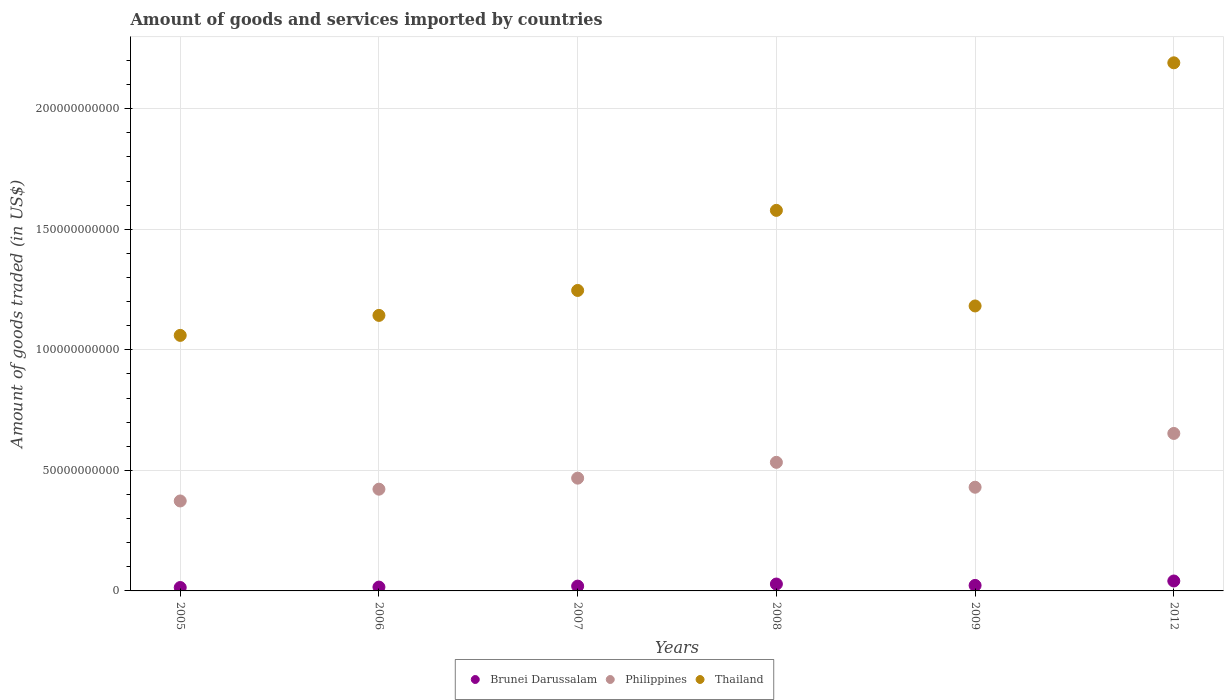Is the number of dotlines equal to the number of legend labels?
Provide a short and direct response. Yes. What is the total amount of goods and services imported in Philippines in 2009?
Your answer should be compact. 4.30e+1. Across all years, what is the maximum total amount of goods and services imported in Brunei Darussalam?
Provide a short and direct response. 4.12e+09. Across all years, what is the minimum total amount of goods and services imported in Brunei Darussalam?
Offer a terse response. 1.41e+09. What is the total total amount of goods and services imported in Brunei Darussalam in the graph?
Your response must be concise. 1.42e+1. What is the difference between the total amount of goods and services imported in Philippines in 2008 and that in 2012?
Provide a short and direct response. -1.20e+1. What is the difference between the total amount of goods and services imported in Philippines in 2006 and the total amount of goods and services imported in Brunei Darussalam in 2005?
Provide a succinct answer. 4.08e+1. What is the average total amount of goods and services imported in Thailand per year?
Your answer should be very brief. 1.40e+11. In the year 2007, what is the difference between the total amount of goods and services imported in Brunei Darussalam and total amount of goods and services imported in Philippines?
Offer a terse response. -4.48e+1. What is the ratio of the total amount of goods and services imported in Brunei Darussalam in 2006 to that in 2008?
Your answer should be compact. 0.56. Is the total amount of goods and services imported in Philippines in 2005 less than that in 2008?
Offer a terse response. Yes. What is the difference between the highest and the second highest total amount of goods and services imported in Philippines?
Your answer should be very brief. 1.20e+1. What is the difference between the highest and the lowest total amount of goods and services imported in Philippines?
Your answer should be very brief. 2.80e+1. Is the sum of the total amount of goods and services imported in Thailand in 2006 and 2012 greater than the maximum total amount of goods and services imported in Brunei Darussalam across all years?
Your response must be concise. Yes. Does the total amount of goods and services imported in Thailand monotonically increase over the years?
Your answer should be compact. No. Is the total amount of goods and services imported in Brunei Darussalam strictly greater than the total amount of goods and services imported in Philippines over the years?
Your answer should be compact. No. Is the total amount of goods and services imported in Thailand strictly less than the total amount of goods and services imported in Brunei Darussalam over the years?
Your answer should be very brief. No. What is the difference between two consecutive major ticks on the Y-axis?
Keep it short and to the point. 5.00e+1. Are the values on the major ticks of Y-axis written in scientific E-notation?
Provide a succinct answer. No. Does the graph contain any zero values?
Your answer should be compact. No. How are the legend labels stacked?
Ensure brevity in your answer.  Horizontal. What is the title of the graph?
Offer a very short reply. Amount of goods and services imported by countries. What is the label or title of the X-axis?
Provide a succinct answer. Years. What is the label or title of the Y-axis?
Your response must be concise. Amount of goods traded (in US$). What is the Amount of goods traded (in US$) in Brunei Darussalam in 2005?
Your response must be concise. 1.41e+09. What is the Amount of goods traded (in US$) in Philippines in 2005?
Give a very brief answer. 3.73e+1. What is the Amount of goods traded (in US$) in Thailand in 2005?
Your response must be concise. 1.06e+11. What is the Amount of goods traded (in US$) of Brunei Darussalam in 2006?
Ensure brevity in your answer.  1.59e+09. What is the Amount of goods traded (in US$) in Philippines in 2006?
Make the answer very short. 4.22e+1. What is the Amount of goods traded (in US$) in Thailand in 2006?
Your answer should be compact. 1.14e+11. What is the Amount of goods traded (in US$) of Brunei Darussalam in 2007?
Your answer should be compact. 1.99e+09. What is the Amount of goods traded (in US$) of Philippines in 2007?
Your answer should be compact. 4.68e+1. What is the Amount of goods traded (in US$) of Thailand in 2007?
Your answer should be compact. 1.25e+11. What is the Amount of goods traded (in US$) in Brunei Darussalam in 2008?
Offer a terse response. 2.86e+09. What is the Amount of goods traded (in US$) of Philippines in 2008?
Make the answer very short. 5.33e+1. What is the Amount of goods traded (in US$) of Thailand in 2008?
Give a very brief answer. 1.58e+11. What is the Amount of goods traded (in US$) of Brunei Darussalam in 2009?
Offer a very short reply. 2.28e+09. What is the Amount of goods traded (in US$) in Philippines in 2009?
Your response must be concise. 4.30e+1. What is the Amount of goods traded (in US$) of Thailand in 2009?
Provide a short and direct response. 1.18e+11. What is the Amount of goods traded (in US$) of Brunei Darussalam in 2012?
Provide a short and direct response. 4.12e+09. What is the Amount of goods traded (in US$) of Philippines in 2012?
Provide a short and direct response. 6.53e+1. What is the Amount of goods traded (in US$) of Thailand in 2012?
Offer a very short reply. 2.19e+11. Across all years, what is the maximum Amount of goods traded (in US$) of Brunei Darussalam?
Offer a very short reply. 4.12e+09. Across all years, what is the maximum Amount of goods traded (in US$) in Philippines?
Provide a short and direct response. 6.53e+1. Across all years, what is the maximum Amount of goods traded (in US$) of Thailand?
Provide a short and direct response. 2.19e+11. Across all years, what is the minimum Amount of goods traded (in US$) in Brunei Darussalam?
Provide a short and direct response. 1.41e+09. Across all years, what is the minimum Amount of goods traded (in US$) of Philippines?
Keep it short and to the point. 3.73e+1. Across all years, what is the minimum Amount of goods traded (in US$) of Thailand?
Make the answer very short. 1.06e+11. What is the total Amount of goods traded (in US$) of Brunei Darussalam in the graph?
Offer a very short reply. 1.42e+1. What is the total Amount of goods traded (in US$) of Philippines in the graph?
Make the answer very short. 2.88e+11. What is the total Amount of goods traded (in US$) of Thailand in the graph?
Provide a succinct answer. 8.40e+11. What is the difference between the Amount of goods traded (in US$) of Brunei Darussalam in 2005 and that in 2006?
Your answer should be very brief. -1.77e+08. What is the difference between the Amount of goods traded (in US$) in Philippines in 2005 and that in 2006?
Keep it short and to the point. -4.89e+09. What is the difference between the Amount of goods traded (in US$) in Thailand in 2005 and that in 2006?
Give a very brief answer. -8.29e+09. What is the difference between the Amount of goods traded (in US$) of Brunei Darussalam in 2005 and that in 2007?
Your response must be concise. -5.80e+08. What is the difference between the Amount of goods traded (in US$) of Philippines in 2005 and that in 2007?
Your response must be concise. -9.46e+09. What is the difference between the Amount of goods traded (in US$) in Thailand in 2005 and that in 2007?
Your response must be concise. -1.86e+1. What is the difference between the Amount of goods traded (in US$) of Brunei Darussalam in 2005 and that in 2008?
Ensure brevity in your answer.  -1.45e+09. What is the difference between the Amount of goods traded (in US$) of Philippines in 2005 and that in 2008?
Offer a terse response. -1.60e+1. What is the difference between the Amount of goods traded (in US$) in Thailand in 2005 and that in 2008?
Offer a terse response. -5.18e+1. What is the difference between the Amount of goods traded (in US$) in Brunei Darussalam in 2005 and that in 2009?
Give a very brief answer. -8.71e+08. What is the difference between the Amount of goods traded (in US$) of Philippines in 2005 and that in 2009?
Your answer should be very brief. -5.70e+09. What is the difference between the Amount of goods traded (in US$) of Thailand in 2005 and that in 2009?
Provide a short and direct response. -1.22e+1. What is the difference between the Amount of goods traded (in US$) in Brunei Darussalam in 2005 and that in 2012?
Offer a terse response. -2.70e+09. What is the difference between the Amount of goods traded (in US$) in Philippines in 2005 and that in 2012?
Provide a short and direct response. -2.80e+1. What is the difference between the Amount of goods traded (in US$) of Thailand in 2005 and that in 2012?
Provide a short and direct response. -1.13e+11. What is the difference between the Amount of goods traded (in US$) in Brunei Darussalam in 2006 and that in 2007?
Ensure brevity in your answer.  -4.03e+08. What is the difference between the Amount of goods traded (in US$) in Philippines in 2006 and that in 2007?
Provide a succinct answer. -4.58e+09. What is the difference between the Amount of goods traded (in US$) in Thailand in 2006 and that in 2007?
Ensure brevity in your answer.  -1.03e+1. What is the difference between the Amount of goods traded (in US$) in Brunei Darussalam in 2006 and that in 2008?
Provide a succinct answer. -1.27e+09. What is the difference between the Amount of goods traded (in US$) in Philippines in 2006 and that in 2008?
Your answer should be compact. -1.11e+1. What is the difference between the Amount of goods traded (in US$) of Thailand in 2006 and that in 2008?
Your answer should be very brief. -4.36e+1. What is the difference between the Amount of goods traded (in US$) of Brunei Darussalam in 2006 and that in 2009?
Ensure brevity in your answer.  -6.94e+08. What is the difference between the Amount of goods traded (in US$) in Philippines in 2006 and that in 2009?
Ensure brevity in your answer.  -8.09e+08. What is the difference between the Amount of goods traded (in US$) in Thailand in 2006 and that in 2009?
Your answer should be very brief. -3.92e+09. What is the difference between the Amount of goods traded (in US$) of Brunei Darussalam in 2006 and that in 2012?
Your answer should be compact. -2.53e+09. What is the difference between the Amount of goods traded (in US$) of Philippines in 2006 and that in 2012?
Your answer should be compact. -2.31e+1. What is the difference between the Amount of goods traded (in US$) in Thailand in 2006 and that in 2012?
Your answer should be compact. -1.05e+11. What is the difference between the Amount of goods traded (in US$) in Brunei Darussalam in 2007 and that in 2008?
Your answer should be compact. -8.66e+08. What is the difference between the Amount of goods traded (in US$) of Philippines in 2007 and that in 2008?
Offer a very short reply. -6.56e+09. What is the difference between the Amount of goods traded (in US$) of Thailand in 2007 and that in 2008?
Offer a very short reply. -3.32e+1. What is the difference between the Amount of goods traded (in US$) of Brunei Darussalam in 2007 and that in 2009?
Provide a succinct answer. -2.91e+08. What is the difference between the Amount of goods traded (in US$) of Philippines in 2007 and that in 2009?
Give a very brief answer. 3.77e+09. What is the difference between the Amount of goods traded (in US$) of Thailand in 2007 and that in 2009?
Offer a terse response. 6.43e+09. What is the difference between the Amount of goods traded (in US$) of Brunei Darussalam in 2007 and that in 2012?
Keep it short and to the point. -2.12e+09. What is the difference between the Amount of goods traded (in US$) in Philippines in 2007 and that in 2012?
Your answer should be very brief. -1.85e+1. What is the difference between the Amount of goods traded (in US$) in Thailand in 2007 and that in 2012?
Give a very brief answer. -9.44e+1. What is the difference between the Amount of goods traded (in US$) of Brunei Darussalam in 2008 and that in 2009?
Offer a very short reply. 5.75e+08. What is the difference between the Amount of goods traded (in US$) of Philippines in 2008 and that in 2009?
Give a very brief answer. 1.03e+1. What is the difference between the Amount of goods traded (in US$) of Thailand in 2008 and that in 2009?
Your response must be concise. 3.96e+1. What is the difference between the Amount of goods traded (in US$) in Brunei Darussalam in 2008 and that in 2012?
Offer a very short reply. -1.26e+09. What is the difference between the Amount of goods traded (in US$) in Philippines in 2008 and that in 2012?
Provide a succinct answer. -1.20e+1. What is the difference between the Amount of goods traded (in US$) of Thailand in 2008 and that in 2012?
Your answer should be compact. -6.12e+1. What is the difference between the Amount of goods traded (in US$) of Brunei Darussalam in 2009 and that in 2012?
Provide a short and direct response. -1.83e+09. What is the difference between the Amount of goods traded (in US$) in Philippines in 2009 and that in 2012?
Give a very brief answer. -2.23e+1. What is the difference between the Amount of goods traded (in US$) in Thailand in 2009 and that in 2012?
Your answer should be very brief. -1.01e+11. What is the difference between the Amount of goods traded (in US$) in Brunei Darussalam in 2005 and the Amount of goods traded (in US$) in Philippines in 2006?
Make the answer very short. -4.08e+1. What is the difference between the Amount of goods traded (in US$) in Brunei Darussalam in 2005 and the Amount of goods traded (in US$) in Thailand in 2006?
Make the answer very short. -1.13e+11. What is the difference between the Amount of goods traded (in US$) of Philippines in 2005 and the Amount of goods traded (in US$) of Thailand in 2006?
Give a very brief answer. -7.70e+1. What is the difference between the Amount of goods traded (in US$) of Brunei Darussalam in 2005 and the Amount of goods traded (in US$) of Philippines in 2007?
Make the answer very short. -4.54e+1. What is the difference between the Amount of goods traded (in US$) of Brunei Darussalam in 2005 and the Amount of goods traded (in US$) of Thailand in 2007?
Provide a succinct answer. -1.23e+11. What is the difference between the Amount of goods traded (in US$) in Philippines in 2005 and the Amount of goods traded (in US$) in Thailand in 2007?
Offer a terse response. -8.73e+1. What is the difference between the Amount of goods traded (in US$) of Brunei Darussalam in 2005 and the Amount of goods traded (in US$) of Philippines in 2008?
Your answer should be very brief. -5.19e+1. What is the difference between the Amount of goods traded (in US$) of Brunei Darussalam in 2005 and the Amount of goods traded (in US$) of Thailand in 2008?
Your answer should be very brief. -1.56e+11. What is the difference between the Amount of goods traded (in US$) in Philippines in 2005 and the Amount of goods traded (in US$) in Thailand in 2008?
Your answer should be very brief. -1.21e+11. What is the difference between the Amount of goods traded (in US$) of Brunei Darussalam in 2005 and the Amount of goods traded (in US$) of Philippines in 2009?
Keep it short and to the point. -4.16e+1. What is the difference between the Amount of goods traded (in US$) in Brunei Darussalam in 2005 and the Amount of goods traded (in US$) in Thailand in 2009?
Your answer should be very brief. -1.17e+11. What is the difference between the Amount of goods traded (in US$) in Philippines in 2005 and the Amount of goods traded (in US$) in Thailand in 2009?
Provide a succinct answer. -8.09e+1. What is the difference between the Amount of goods traded (in US$) of Brunei Darussalam in 2005 and the Amount of goods traded (in US$) of Philippines in 2012?
Your response must be concise. -6.39e+1. What is the difference between the Amount of goods traded (in US$) of Brunei Darussalam in 2005 and the Amount of goods traded (in US$) of Thailand in 2012?
Your answer should be compact. -2.18e+11. What is the difference between the Amount of goods traded (in US$) in Philippines in 2005 and the Amount of goods traded (in US$) in Thailand in 2012?
Provide a short and direct response. -1.82e+11. What is the difference between the Amount of goods traded (in US$) in Brunei Darussalam in 2006 and the Amount of goods traded (in US$) in Philippines in 2007?
Offer a terse response. -4.52e+1. What is the difference between the Amount of goods traded (in US$) in Brunei Darussalam in 2006 and the Amount of goods traded (in US$) in Thailand in 2007?
Provide a short and direct response. -1.23e+11. What is the difference between the Amount of goods traded (in US$) in Philippines in 2006 and the Amount of goods traded (in US$) in Thailand in 2007?
Provide a short and direct response. -8.24e+1. What is the difference between the Amount of goods traded (in US$) of Brunei Darussalam in 2006 and the Amount of goods traded (in US$) of Philippines in 2008?
Provide a short and direct response. -5.17e+1. What is the difference between the Amount of goods traded (in US$) in Brunei Darussalam in 2006 and the Amount of goods traded (in US$) in Thailand in 2008?
Make the answer very short. -1.56e+11. What is the difference between the Amount of goods traded (in US$) in Philippines in 2006 and the Amount of goods traded (in US$) in Thailand in 2008?
Make the answer very short. -1.16e+11. What is the difference between the Amount of goods traded (in US$) of Brunei Darussalam in 2006 and the Amount of goods traded (in US$) of Philippines in 2009?
Give a very brief answer. -4.14e+1. What is the difference between the Amount of goods traded (in US$) of Brunei Darussalam in 2006 and the Amount of goods traded (in US$) of Thailand in 2009?
Ensure brevity in your answer.  -1.17e+11. What is the difference between the Amount of goods traded (in US$) of Philippines in 2006 and the Amount of goods traded (in US$) of Thailand in 2009?
Provide a succinct answer. -7.60e+1. What is the difference between the Amount of goods traded (in US$) of Brunei Darussalam in 2006 and the Amount of goods traded (in US$) of Philippines in 2012?
Offer a terse response. -6.37e+1. What is the difference between the Amount of goods traded (in US$) of Brunei Darussalam in 2006 and the Amount of goods traded (in US$) of Thailand in 2012?
Provide a succinct answer. -2.17e+11. What is the difference between the Amount of goods traded (in US$) of Philippines in 2006 and the Amount of goods traded (in US$) of Thailand in 2012?
Give a very brief answer. -1.77e+11. What is the difference between the Amount of goods traded (in US$) in Brunei Darussalam in 2007 and the Amount of goods traded (in US$) in Philippines in 2008?
Make the answer very short. -5.13e+1. What is the difference between the Amount of goods traded (in US$) of Brunei Darussalam in 2007 and the Amount of goods traded (in US$) of Thailand in 2008?
Provide a succinct answer. -1.56e+11. What is the difference between the Amount of goods traded (in US$) of Philippines in 2007 and the Amount of goods traded (in US$) of Thailand in 2008?
Offer a very short reply. -1.11e+11. What is the difference between the Amount of goods traded (in US$) of Brunei Darussalam in 2007 and the Amount of goods traded (in US$) of Philippines in 2009?
Your response must be concise. -4.10e+1. What is the difference between the Amount of goods traded (in US$) in Brunei Darussalam in 2007 and the Amount of goods traded (in US$) in Thailand in 2009?
Give a very brief answer. -1.16e+11. What is the difference between the Amount of goods traded (in US$) in Philippines in 2007 and the Amount of goods traded (in US$) in Thailand in 2009?
Make the answer very short. -7.14e+1. What is the difference between the Amount of goods traded (in US$) of Brunei Darussalam in 2007 and the Amount of goods traded (in US$) of Philippines in 2012?
Your answer should be very brief. -6.33e+1. What is the difference between the Amount of goods traded (in US$) in Brunei Darussalam in 2007 and the Amount of goods traded (in US$) in Thailand in 2012?
Offer a very short reply. -2.17e+11. What is the difference between the Amount of goods traded (in US$) in Philippines in 2007 and the Amount of goods traded (in US$) in Thailand in 2012?
Ensure brevity in your answer.  -1.72e+11. What is the difference between the Amount of goods traded (in US$) of Brunei Darussalam in 2008 and the Amount of goods traded (in US$) of Philippines in 2009?
Your answer should be very brief. -4.01e+1. What is the difference between the Amount of goods traded (in US$) of Brunei Darussalam in 2008 and the Amount of goods traded (in US$) of Thailand in 2009?
Offer a terse response. -1.15e+11. What is the difference between the Amount of goods traded (in US$) of Philippines in 2008 and the Amount of goods traded (in US$) of Thailand in 2009?
Your answer should be very brief. -6.49e+1. What is the difference between the Amount of goods traded (in US$) in Brunei Darussalam in 2008 and the Amount of goods traded (in US$) in Philippines in 2012?
Your answer should be very brief. -6.25e+1. What is the difference between the Amount of goods traded (in US$) in Brunei Darussalam in 2008 and the Amount of goods traded (in US$) in Thailand in 2012?
Give a very brief answer. -2.16e+11. What is the difference between the Amount of goods traded (in US$) of Philippines in 2008 and the Amount of goods traded (in US$) of Thailand in 2012?
Ensure brevity in your answer.  -1.66e+11. What is the difference between the Amount of goods traded (in US$) of Brunei Darussalam in 2009 and the Amount of goods traded (in US$) of Philippines in 2012?
Ensure brevity in your answer.  -6.30e+1. What is the difference between the Amount of goods traded (in US$) of Brunei Darussalam in 2009 and the Amount of goods traded (in US$) of Thailand in 2012?
Offer a terse response. -2.17e+11. What is the difference between the Amount of goods traded (in US$) of Philippines in 2009 and the Amount of goods traded (in US$) of Thailand in 2012?
Ensure brevity in your answer.  -1.76e+11. What is the average Amount of goods traded (in US$) in Brunei Darussalam per year?
Your answer should be compact. 2.37e+09. What is the average Amount of goods traded (in US$) in Philippines per year?
Your response must be concise. 4.80e+1. What is the average Amount of goods traded (in US$) of Thailand per year?
Provide a short and direct response. 1.40e+11. In the year 2005, what is the difference between the Amount of goods traded (in US$) of Brunei Darussalam and Amount of goods traded (in US$) of Philippines?
Offer a very short reply. -3.59e+1. In the year 2005, what is the difference between the Amount of goods traded (in US$) in Brunei Darussalam and Amount of goods traded (in US$) in Thailand?
Give a very brief answer. -1.05e+11. In the year 2005, what is the difference between the Amount of goods traded (in US$) in Philippines and Amount of goods traded (in US$) in Thailand?
Your answer should be compact. -6.87e+1. In the year 2006, what is the difference between the Amount of goods traded (in US$) in Brunei Darussalam and Amount of goods traded (in US$) in Philippines?
Offer a terse response. -4.06e+1. In the year 2006, what is the difference between the Amount of goods traded (in US$) in Brunei Darussalam and Amount of goods traded (in US$) in Thailand?
Give a very brief answer. -1.13e+11. In the year 2006, what is the difference between the Amount of goods traded (in US$) in Philippines and Amount of goods traded (in US$) in Thailand?
Ensure brevity in your answer.  -7.21e+1. In the year 2007, what is the difference between the Amount of goods traded (in US$) of Brunei Darussalam and Amount of goods traded (in US$) of Philippines?
Give a very brief answer. -4.48e+1. In the year 2007, what is the difference between the Amount of goods traded (in US$) of Brunei Darussalam and Amount of goods traded (in US$) of Thailand?
Your response must be concise. -1.23e+11. In the year 2007, what is the difference between the Amount of goods traded (in US$) in Philippines and Amount of goods traded (in US$) in Thailand?
Make the answer very short. -7.78e+1. In the year 2008, what is the difference between the Amount of goods traded (in US$) in Brunei Darussalam and Amount of goods traded (in US$) in Philippines?
Offer a terse response. -5.05e+1. In the year 2008, what is the difference between the Amount of goods traded (in US$) of Brunei Darussalam and Amount of goods traded (in US$) of Thailand?
Offer a very short reply. -1.55e+11. In the year 2008, what is the difference between the Amount of goods traded (in US$) in Philippines and Amount of goods traded (in US$) in Thailand?
Offer a terse response. -1.04e+11. In the year 2009, what is the difference between the Amount of goods traded (in US$) of Brunei Darussalam and Amount of goods traded (in US$) of Philippines?
Your response must be concise. -4.07e+1. In the year 2009, what is the difference between the Amount of goods traded (in US$) in Brunei Darussalam and Amount of goods traded (in US$) in Thailand?
Your response must be concise. -1.16e+11. In the year 2009, what is the difference between the Amount of goods traded (in US$) in Philippines and Amount of goods traded (in US$) in Thailand?
Provide a succinct answer. -7.52e+1. In the year 2012, what is the difference between the Amount of goods traded (in US$) of Brunei Darussalam and Amount of goods traded (in US$) of Philippines?
Your answer should be very brief. -6.12e+1. In the year 2012, what is the difference between the Amount of goods traded (in US$) in Brunei Darussalam and Amount of goods traded (in US$) in Thailand?
Offer a terse response. -2.15e+11. In the year 2012, what is the difference between the Amount of goods traded (in US$) in Philippines and Amount of goods traded (in US$) in Thailand?
Your answer should be very brief. -1.54e+11. What is the ratio of the Amount of goods traded (in US$) of Brunei Darussalam in 2005 to that in 2006?
Make the answer very short. 0.89. What is the ratio of the Amount of goods traded (in US$) of Philippines in 2005 to that in 2006?
Make the answer very short. 0.88. What is the ratio of the Amount of goods traded (in US$) of Thailand in 2005 to that in 2006?
Your answer should be compact. 0.93. What is the ratio of the Amount of goods traded (in US$) of Brunei Darussalam in 2005 to that in 2007?
Ensure brevity in your answer.  0.71. What is the ratio of the Amount of goods traded (in US$) of Philippines in 2005 to that in 2007?
Ensure brevity in your answer.  0.8. What is the ratio of the Amount of goods traded (in US$) in Thailand in 2005 to that in 2007?
Your answer should be compact. 0.85. What is the ratio of the Amount of goods traded (in US$) of Brunei Darussalam in 2005 to that in 2008?
Offer a very short reply. 0.49. What is the ratio of the Amount of goods traded (in US$) of Philippines in 2005 to that in 2008?
Provide a short and direct response. 0.7. What is the ratio of the Amount of goods traded (in US$) of Thailand in 2005 to that in 2008?
Offer a terse response. 0.67. What is the ratio of the Amount of goods traded (in US$) of Brunei Darussalam in 2005 to that in 2009?
Offer a very short reply. 0.62. What is the ratio of the Amount of goods traded (in US$) in Philippines in 2005 to that in 2009?
Your answer should be compact. 0.87. What is the ratio of the Amount of goods traded (in US$) in Thailand in 2005 to that in 2009?
Your answer should be very brief. 0.9. What is the ratio of the Amount of goods traded (in US$) in Brunei Darussalam in 2005 to that in 2012?
Keep it short and to the point. 0.34. What is the ratio of the Amount of goods traded (in US$) of Philippines in 2005 to that in 2012?
Provide a short and direct response. 0.57. What is the ratio of the Amount of goods traded (in US$) of Thailand in 2005 to that in 2012?
Ensure brevity in your answer.  0.48. What is the ratio of the Amount of goods traded (in US$) in Brunei Darussalam in 2006 to that in 2007?
Ensure brevity in your answer.  0.8. What is the ratio of the Amount of goods traded (in US$) in Philippines in 2006 to that in 2007?
Give a very brief answer. 0.9. What is the ratio of the Amount of goods traded (in US$) of Thailand in 2006 to that in 2007?
Keep it short and to the point. 0.92. What is the ratio of the Amount of goods traded (in US$) in Brunei Darussalam in 2006 to that in 2008?
Provide a short and direct response. 0.56. What is the ratio of the Amount of goods traded (in US$) in Philippines in 2006 to that in 2008?
Provide a short and direct response. 0.79. What is the ratio of the Amount of goods traded (in US$) in Thailand in 2006 to that in 2008?
Ensure brevity in your answer.  0.72. What is the ratio of the Amount of goods traded (in US$) in Brunei Darussalam in 2006 to that in 2009?
Keep it short and to the point. 0.7. What is the ratio of the Amount of goods traded (in US$) of Philippines in 2006 to that in 2009?
Your answer should be compact. 0.98. What is the ratio of the Amount of goods traded (in US$) in Thailand in 2006 to that in 2009?
Make the answer very short. 0.97. What is the ratio of the Amount of goods traded (in US$) of Brunei Darussalam in 2006 to that in 2012?
Ensure brevity in your answer.  0.39. What is the ratio of the Amount of goods traded (in US$) in Philippines in 2006 to that in 2012?
Your answer should be compact. 0.65. What is the ratio of the Amount of goods traded (in US$) of Thailand in 2006 to that in 2012?
Provide a short and direct response. 0.52. What is the ratio of the Amount of goods traded (in US$) of Brunei Darussalam in 2007 to that in 2008?
Give a very brief answer. 0.7. What is the ratio of the Amount of goods traded (in US$) of Philippines in 2007 to that in 2008?
Make the answer very short. 0.88. What is the ratio of the Amount of goods traded (in US$) in Thailand in 2007 to that in 2008?
Your response must be concise. 0.79. What is the ratio of the Amount of goods traded (in US$) of Brunei Darussalam in 2007 to that in 2009?
Keep it short and to the point. 0.87. What is the ratio of the Amount of goods traded (in US$) in Philippines in 2007 to that in 2009?
Your answer should be very brief. 1.09. What is the ratio of the Amount of goods traded (in US$) of Thailand in 2007 to that in 2009?
Keep it short and to the point. 1.05. What is the ratio of the Amount of goods traded (in US$) in Brunei Darussalam in 2007 to that in 2012?
Offer a very short reply. 0.48. What is the ratio of the Amount of goods traded (in US$) of Philippines in 2007 to that in 2012?
Provide a succinct answer. 0.72. What is the ratio of the Amount of goods traded (in US$) of Thailand in 2007 to that in 2012?
Your answer should be very brief. 0.57. What is the ratio of the Amount of goods traded (in US$) in Brunei Darussalam in 2008 to that in 2009?
Your response must be concise. 1.25. What is the ratio of the Amount of goods traded (in US$) in Philippines in 2008 to that in 2009?
Offer a terse response. 1.24. What is the ratio of the Amount of goods traded (in US$) in Thailand in 2008 to that in 2009?
Make the answer very short. 1.34. What is the ratio of the Amount of goods traded (in US$) of Brunei Darussalam in 2008 to that in 2012?
Provide a succinct answer. 0.69. What is the ratio of the Amount of goods traded (in US$) of Philippines in 2008 to that in 2012?
Ensure brevity in your answer.  0.82. What is the ratio of the Amount of goods traded (in US$) in Thailand in 2008 to that in 2012?
Your answer should be very brief. 0.72. What is the ratio of the Amount of goods traded (in US$) in Brunei Darussalam in 2009 to that in 2012?
Your answer should be very brief. 0.55. What is the ratio of the Amount of goods traded (in US$) of Philippines in 2009 to that in 2012?
Provide a short and direct response. 0.66. What is the ratio of the Amount of goods traded (in US$) of Thailand in 2009 to that in 2012?
Provide a short and direct response. 0.54. What is the difference between the highest and the second highest Amount of goods traded (in US$) of Brunei Darussalam?
Your response must be concise. 1.26e+09. What is the difference between the highest and the second highest Amount of goods traded (in US$) of Philippines?
Your response must be concise. 1.20e+1. What is the difference between the highest and the second highest Amount of goods traded (in US$) of Thailand?
Your answer should be very brief. 6.12e+1. What is the difference between the highest and the lowest Amount of goods traded (in US$) of Brunei Darussalam?
Make the answer very short. 2.70e+09. What is the difference between the highest and the lowest Amount of goods traded (in US$) of Philippines?
Your answer should be compact. 2.80e+1. What is the difference between the highest and the lowest Amount of goods traded (in US$) in Thailand?
Ensure brevity in your answer.  1.13e+11. 